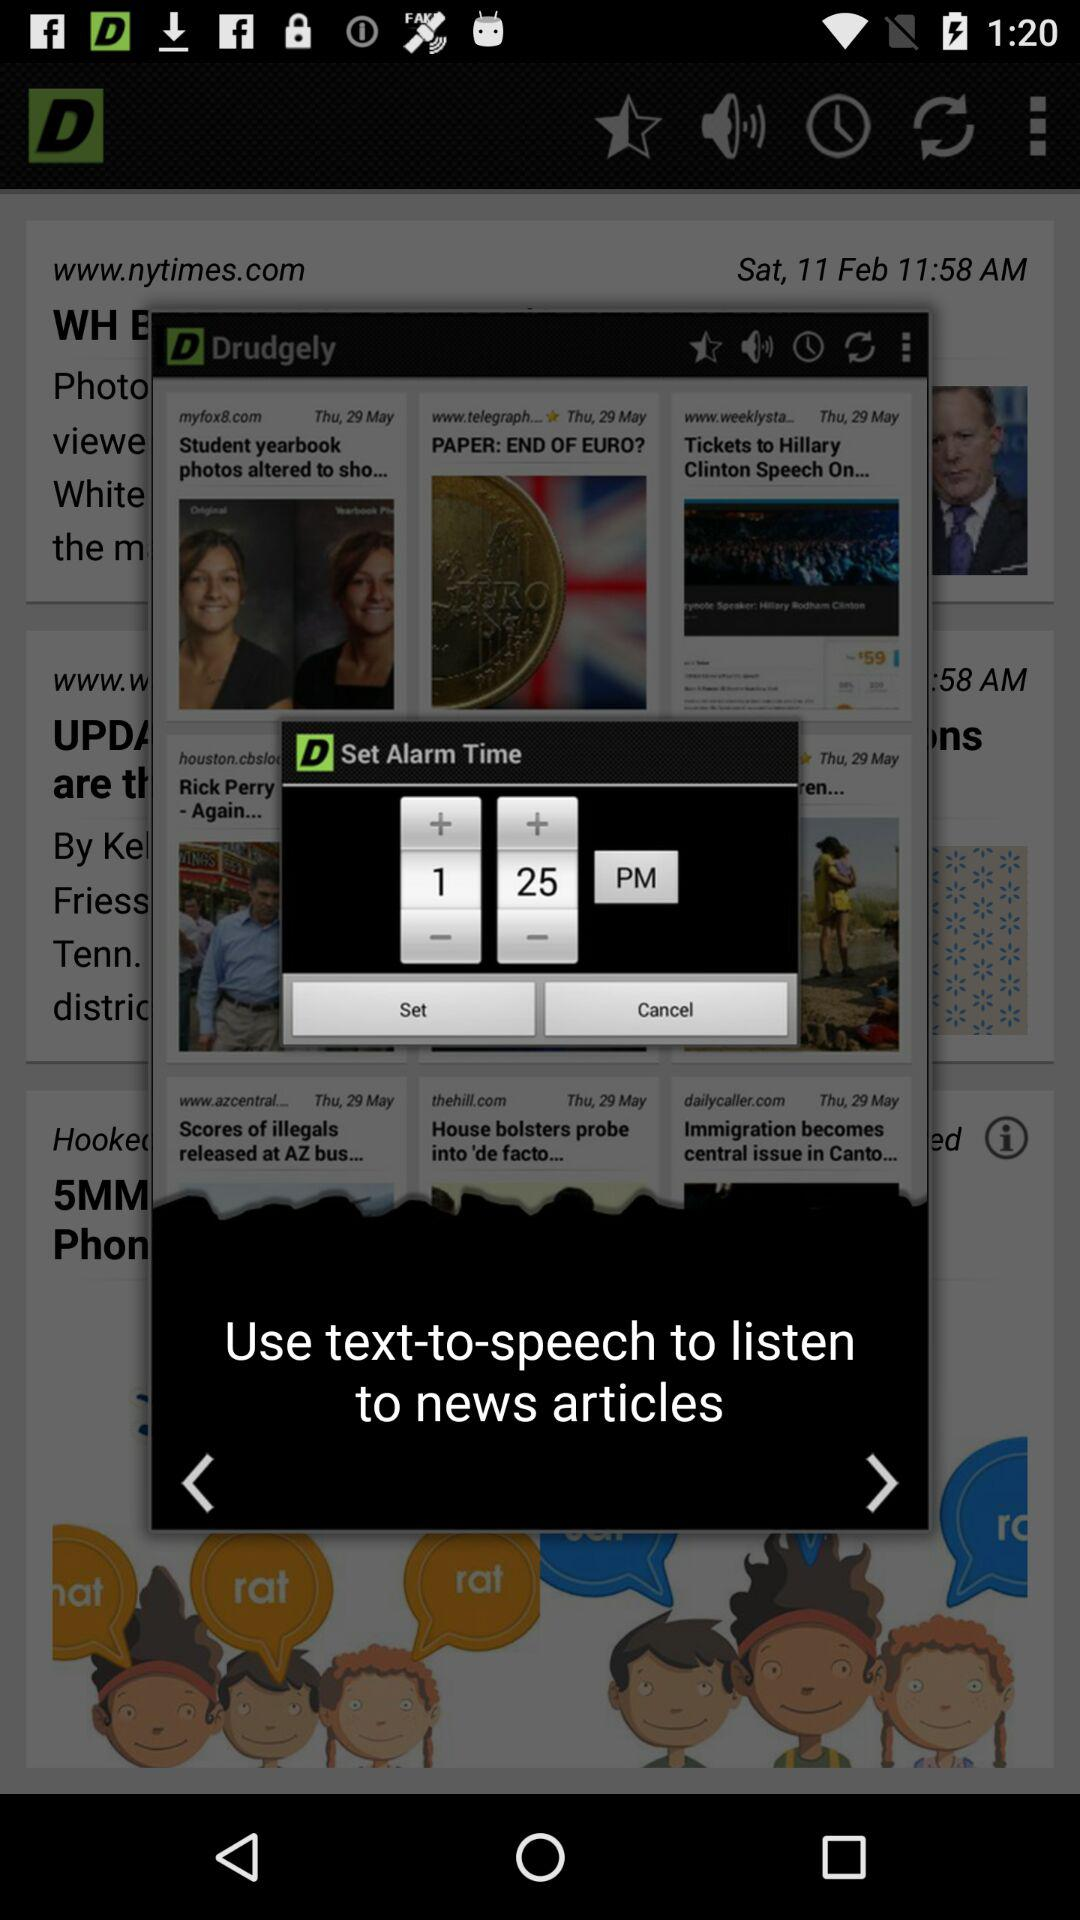What time is the alarm set? The time is 1:25 pm. 